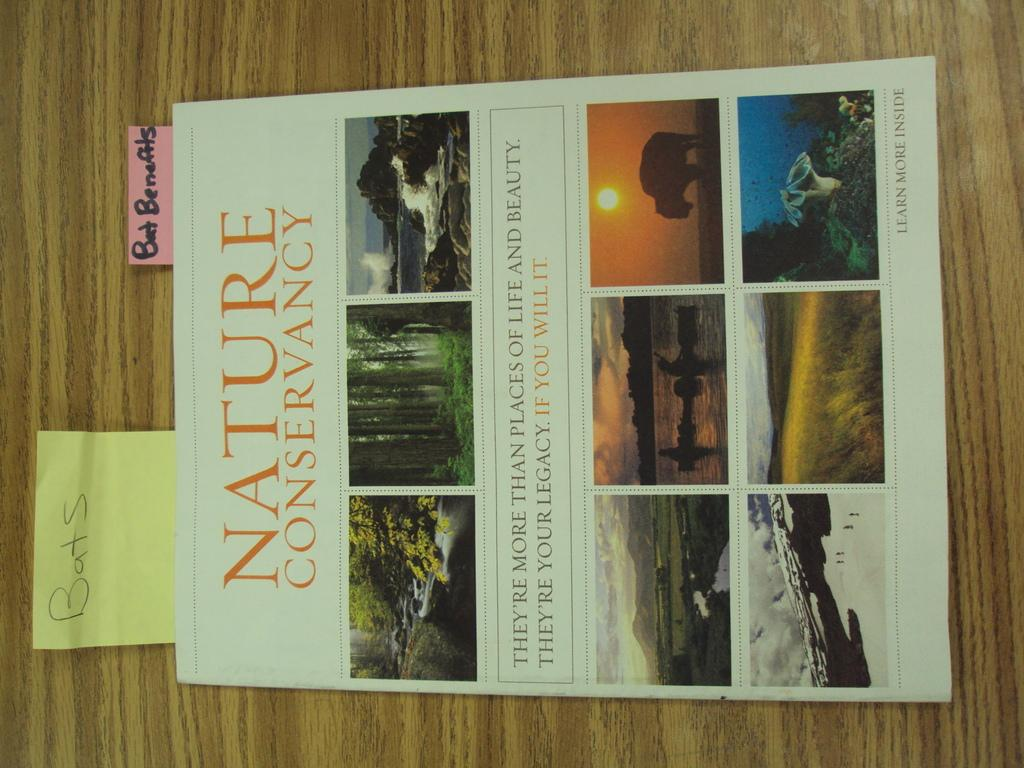<image>
Render a clear and concise summary of the photo. A nature conservation brochure lies on a desk and has post it note sticking out of it. 